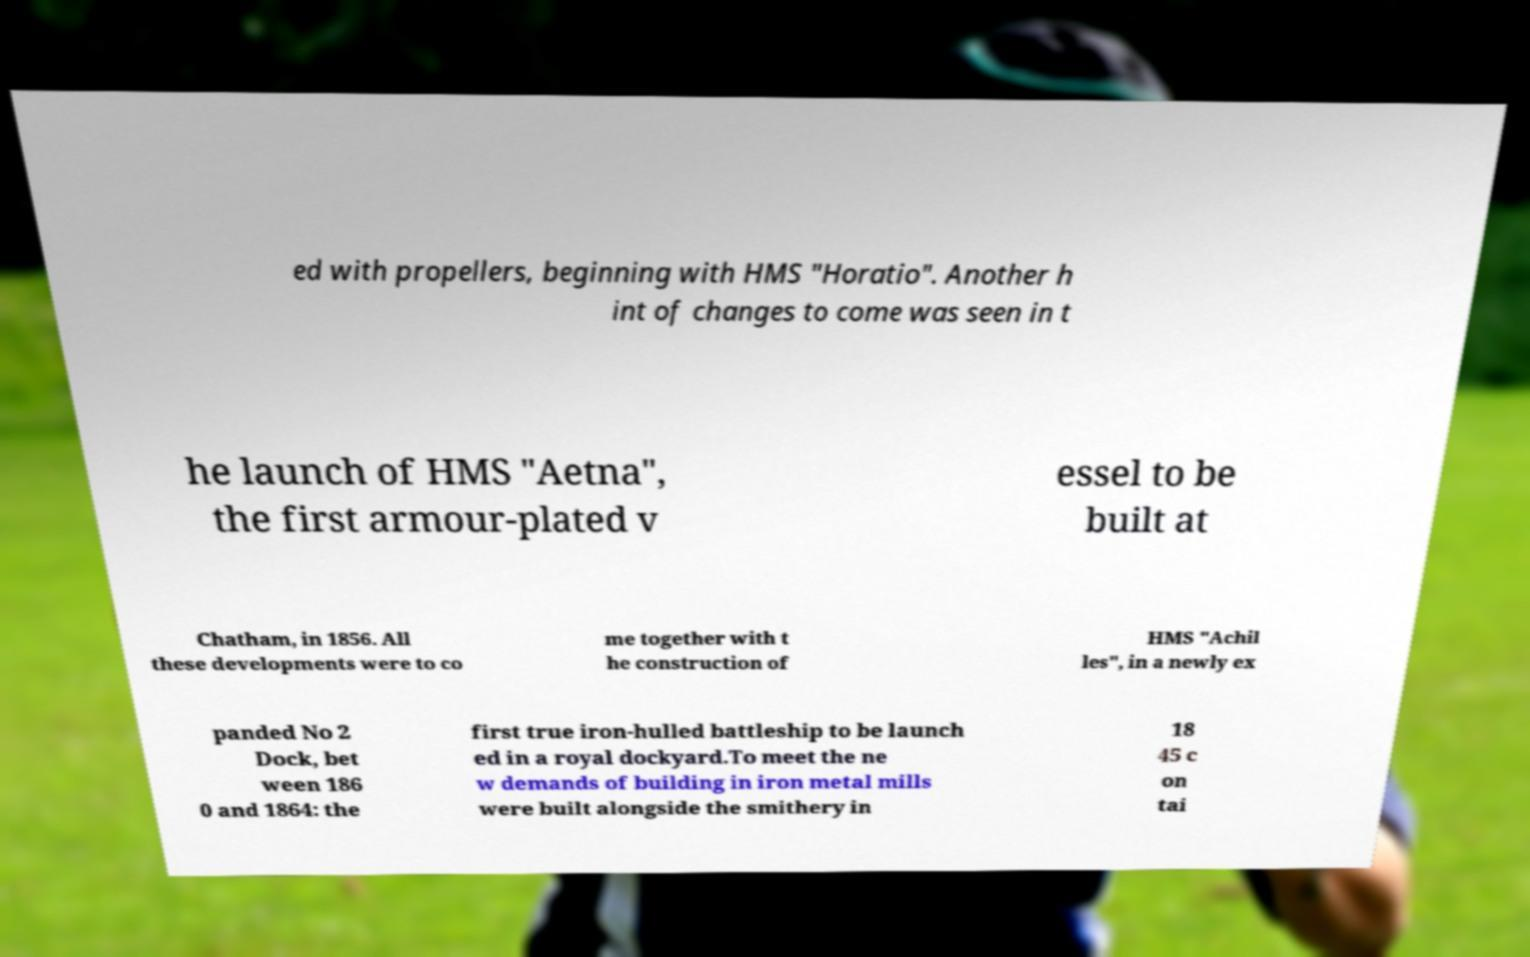For documentation purposes, I need the text within this image transcribed. Could you provide that? ed with propellers, beginning with HMS "Horatio". Another h int of changes to come was seen in t he launch of HMS "Aetna", the first armour-plated v essel to be built at Chatham, in 1856. All these developments were to co me together with t he construction of HMS "Achil les", in a newly ex panded No 2 Dock, bet ween 186 0 and 1864: the first true iron-hulled battleship to be launch ed in a royal dockyard.To meet the ne w demands of building in iron metal mills were built alongside the smithery in 18 45 c on tai 